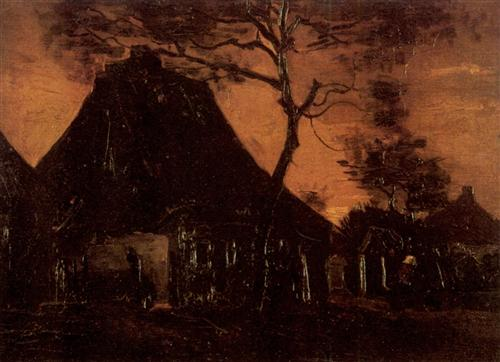Create a poem inspired by this image. In silent lands where twilight dwells,
A cottage stands, a story tells,
Beneath the sky of burning hue,
Dark shadows whisper secrets true.

A tree with branches twisted, bare,
Reaches out in icy air,
Once life within its walls did bloom,
Now echoes linger in the gloom.

Forgotten paths, untrodden ground,
Where dreams in stillness now are bound,
A home for ghosts of time long past,
Their memories in void are cast.

Yet beauty lies within decay,
An artful dance of night and day,
A painting set in sorrow’s frame,
Eternal hush, a whispered name. 